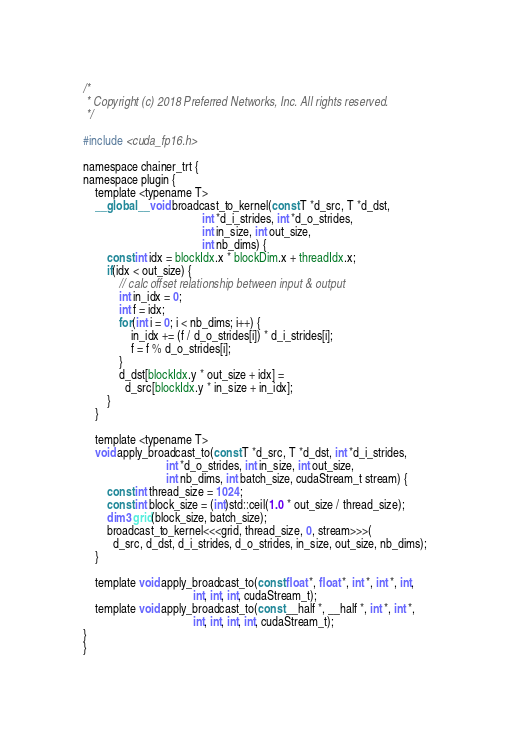<code> <loc_0><loc_0><loc_500><loc_500><_Cuda_>/*
 * Copyright (c) 2018 Preferred Networks, Inc. All rights reserved.
 */

#include <cuda_fp16.h>

namespace chainer_trt {
namespace plugin {
    template <typename T>
    __global__ void broadcast_to_kernel(const T *d_src, T *d_dst,
                                        int *d_i_strides, int *d_o_strides,
                                        int in_size, int out_size,
                                        int nb_dims) {
        const int idx = blockIdx.x * blockDim.x + threadIdx.x;
        if(idx < out_size) {
            // calc offset relationship between input & output
            int in_idx = 0;
            int f = idx;
            for(int i = 0; i < nb_dims; i++) {
                in_idx += (f / d_o_strides[i]) * d_i_strides[i];
                f = f % d_o_strides[i];
            }
            d_dst[blockIdx.y * out_size + idx] =
              d_src[blockIdx.y * in_size + in_idx];
        }
    }

    template <typename T>
    void apply_broadcast_to(const T *d_src, T *d_dst, int *d_i_strides,
                            int *d_o_strides, int in_size, int out_size,
                            int nb_dims, int batch_size, cudaStream_t stream) {
        const int thread_size = 1024;
        const int block_size = (int)std::ceil(1.0 * out_size / thread_size);
        dim3 grid(block_size, batch_size);
        broadcast_to_kernel<<<grid, thread_size, 0, stream>>>(
          d_src, d_dst, d_i_strides, d_o_strides, in_size, out_size, nb_dims);
    }

    template void apply_broadcast_to(const float *, float *, int *, int *, int,
                                     int, int, int, cudaStream_t);
    template void apply_broadcast_to(const __half *, __half *, int *, int *,
                                     int, int, int, int, cudaStream_t);
}
}
</code> 